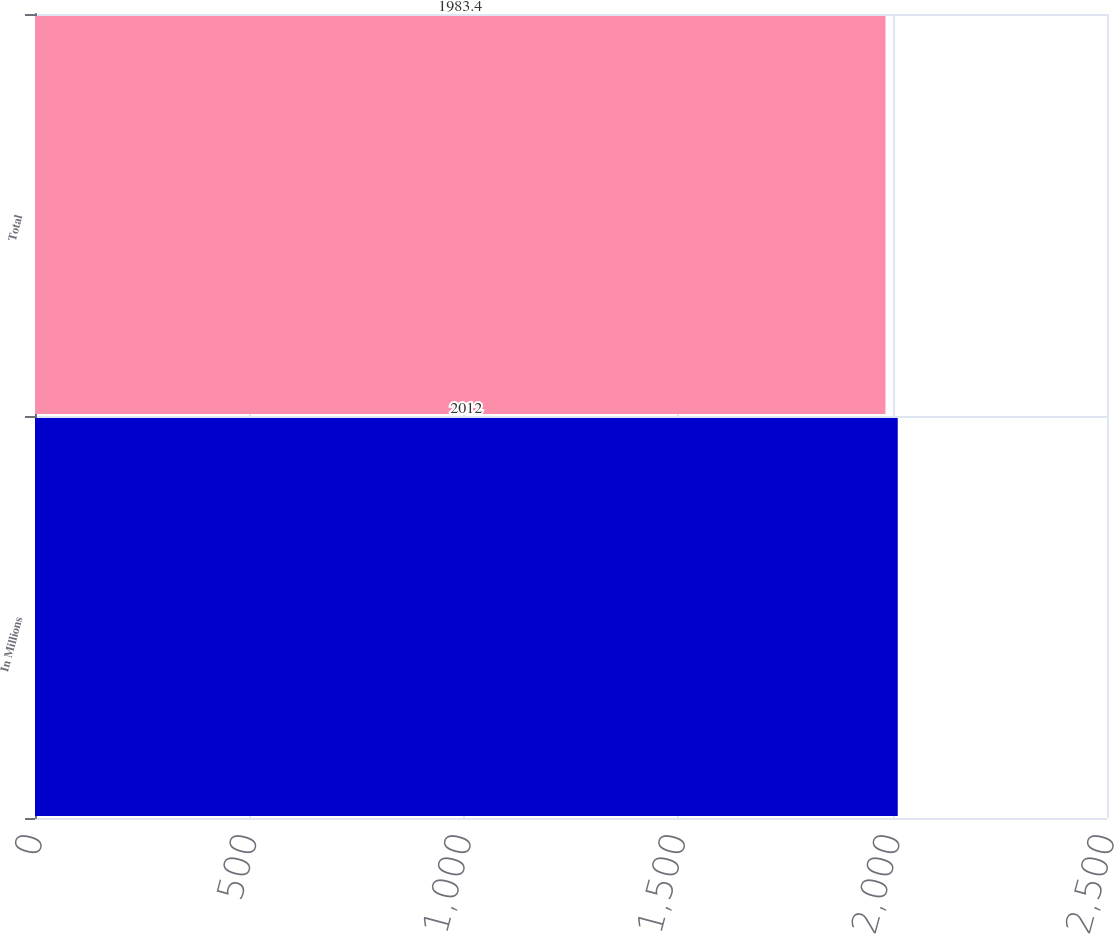<chart> <loc_0><loc_0><loc_500><loc_500><bar_chart><fcel>In Millions<fcel>Total<nl><fcel>2012<fcel>1983.4<nl></chart> 